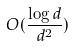<formula> <loc_0><loc_0><loc_500><loc_500>O ( \frac { \log d } { d ^ { 2 } } )</formula> 